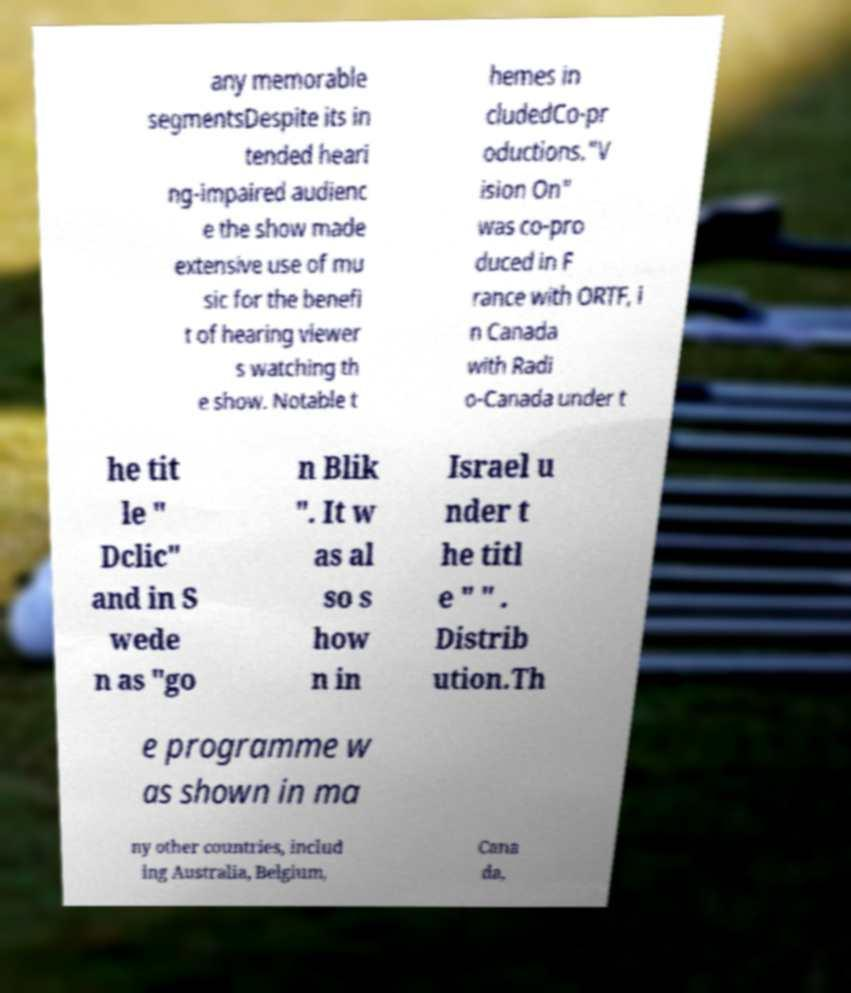For documentation purposes, I need the text within this image transcribed. Could you provide that? any memorable segmentsDespite its in tended heari ng-impaired audienc e the show made extensive use of mu sic for the benefi t of hearing viewer s watching th e show. Notable t hemes in cludedCo-pr oductions."V ision On" was co-pro duced in F rance with ORTF, i n Canada with Radi o-Canada under t he tit le " Dclic" and in S wede n as "go n Blik ". It w as al so s how n in Israel u nder t he titl e " " . Distrib ution.Th e programme w as shown in ma ny other countries, includ ing Australia, Belgium, Cana da, 